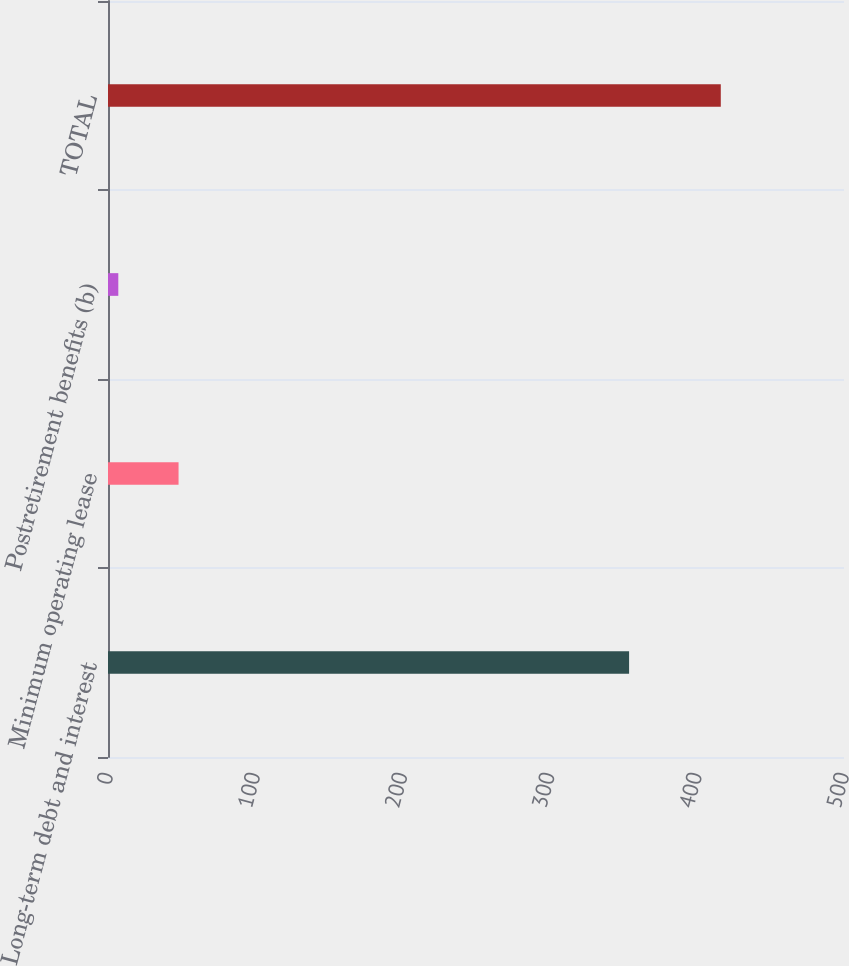Convert chart to OTSL. <chart><loc_0><loc_0><loc_500><loc_500><bar_chart><fcel>Long-term debt and interest<fcel>Minimum operating lease<fcel>Postretirement benefits (b)<fcel>TOTAL<nl><fcel>354<fcel>47.93<fcel>7<fcel>416.3<nl></chart> 